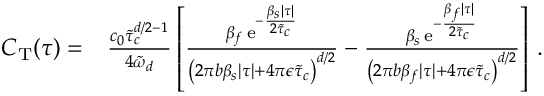<formula> <loc_0><loc_0><loc_500><loc_500>\begin{array} { r l } { C _ { T } ( \tau ) = } & { \frac { c _ { 0 } \tilde { \tau } _ { c } ^ { d / 2 - 1 } } { 4 \tilde { \omega } _ { d } } \left [ \frac { \beta _ { f } \, e ^ { - \frac { \beta _ { s } | \tau | } { 2 \tilde { \tau } _ { c } } } } { \left ( 2 \pi b \beta _ { s } | \tau | + 4 \pi \epsilon \tilde { \tau } _ { c } \right ) ^ { d / 2 } } - \frac { \beta _ { s } \, e ^ { - \frac { \beta _ { f } | \tau | } { 2 \tilde { \tau } _ { c } } } } { \left ( 2 \pi b \beta _ { f } | \tau | + 4 \pi \epsilon \tilde { \tau } _ { c } \right ) ^ { d / 2 } } \right ] \, . } \end{array}</formula> 